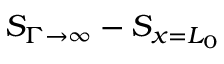Convert formula to latex. <formula><loc_0><loc_0><loc_500><loc_500>S _ { \Gamma \rightarrow \infty } - S _ { x = L _ { 0 } }</formula> 